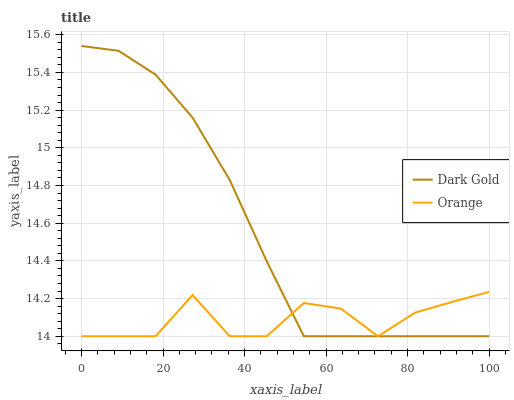Does Orange have the minimum area under the curve?
Answer yes or no. Yes. Does Dark Gold have the maximum area under the curve?
Answer yes or no. Yes. Does Dark Gold have the minimum area under the curve?
Answer yes or no. No. Is Dark Gold the smoothest?
Answer yes or no. Yes. Is Orange the roughest?
Answer yes or no. Yes. Is Dark Gold the roughest?
Answer yes or no. No. Does Orange have the lowest value?
Answer yes or no. Yes. Does Dark Gold have the highest value?
Answer yes or no. Yes. Does Orange intersect Dark Gold?
Answer yes or no. Yes. Is Orange less than Dark Gold?
Answer yes or no. No. Is Orange greater than Dark Gold?
Answer yes or no. No. 